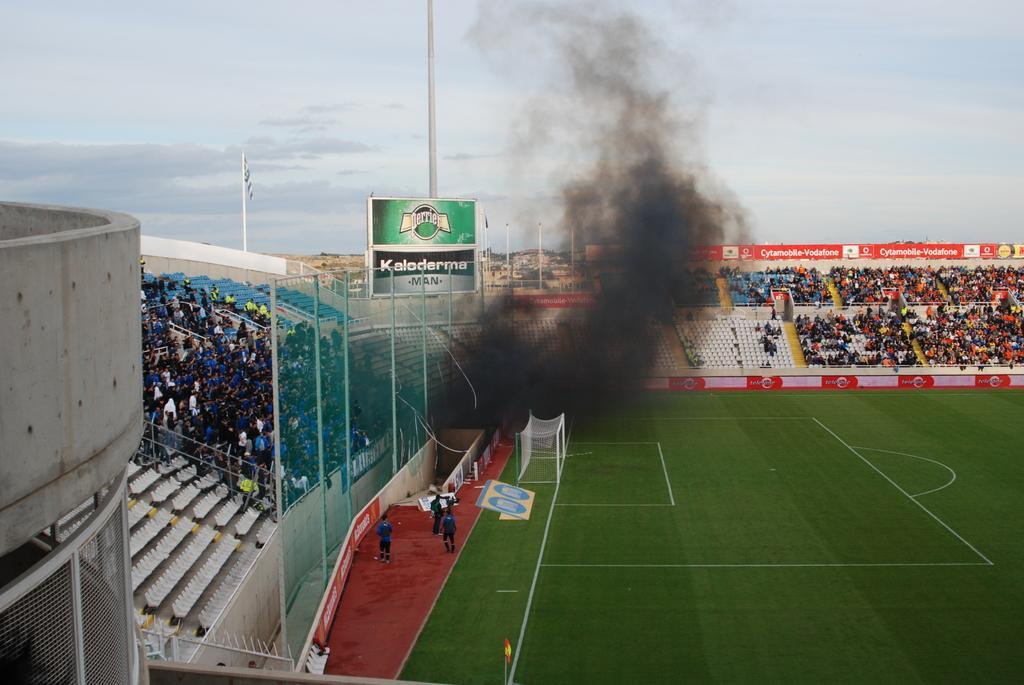Describe this image in one or two sentences. In the image there is a football ground and many people sitting on chairs around it, there is a fence in the front of the chairs and smoke releasing in the middle and above its sky with clouds. 